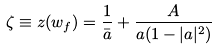<formula> <loc_0><loc_0><loc_500><loc_500>\zeta \equiv z ( w _ { f } ) = \frac { 1 } { \bar { a } } + \frac { A } { a ( 1 - | a | ^ { 2 } ) }</formula> 